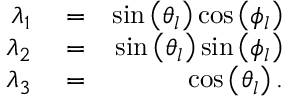Convert formula to latex. <formula><loc_0><loc_0><loc_500><loc_500>\begin{array} { r l r } { \lambda _ { 1 } } & = } & { \sin \left ( \theta _ { l } \right ) \cos \left ( \phi _ { l } \right ) } \\ { \lambda _ { 2 } } & = } & { \sin \left ( \theta _ { l } \right ) \sin \left ( \phi _ { l } \right ) } \\ { \lambda _ { 3 } } & = } & { \cos \left ( \theta _ { l } \right ) . } \end{array}</formula> 